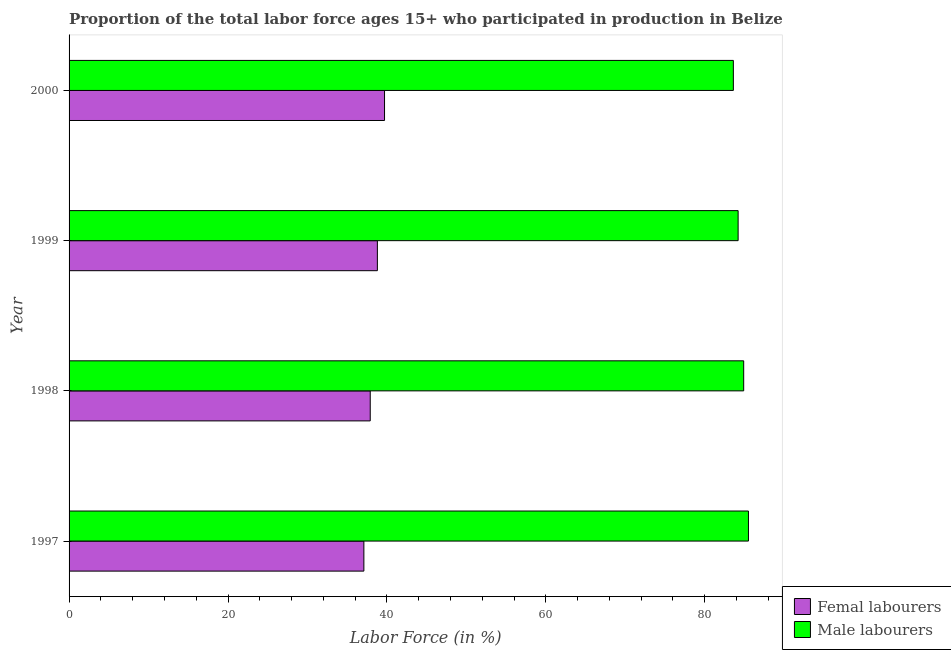How many different coloured bars are there?
Your answer should be very brief. 2. Are the number of bars per tick equal to the number of legend labels?
Your answer should be compact. Yes. Are the number of bars on each tick of the Y-axis equal?
Make the answer very short. Yes. How many bars are there on the 3rd tick from the top?
Ensure brevity in your answer.  2. What is the label of the 3rd group of bars from the top?
Provide a short and direct response. 1998. In how many cases, is the number of bars for a given year not equal to the number of legend labels?
Offer a terse response. 0. What is the percentage of male labour force in 2000?
Your answer should be compact. 83.6. Across all years, what is the maximum percentage of female labor force?
Your answer should be very brief. 39.7. Across all years, what is the minimum percentage of male labour force?
Offer a very short reply. 83.6. In which year was the percentage of male labour force maximum?
Offer a terse response. 1997. What is the total percentage of male labour force in the graph?
Ensure brevity in your answer.  338.2. What is the difference between the percentage of female labor force in 1997 and that in 1999?
Your response must be concise. -1.7. What is the difference between the percentage of male labour force in 1998 and the percentage of female labor force in 2000?
Make the answer very short. 45.2. What is the average percentage of female labor force per year?
Offer a very short reply. 38.38. In the year 1999, what is the difference between the percentage of female labor force and percentage of male labour force?
Provide a succinct answer. -45.4. What is the difference between the highest and the second highest percentage of male labour force?
Provide a succinct answer. 0.6. Is the sum of the percentage of male labour force in 1999 and 2000 greater than the maximum percentage of female labor force across all years?
Offer a very short reply. Yes. What does the 2nd bar from the top in 2000 represents?
Offer a very short reply. Femal labourers. What does the 1st bar from the bottom in 1998 represents?
Provide a short and direct response. Femal labourers. Are the values on the major ticks of X-axis written in scientific E-notation?
Provide a short and direct response. No. Does the graph contain any zero values?
Ensure brevity in your answer.  No. How many legend labels are there?
Your answer should be very brief. 2. How are the legend labels stacked?
Your answer should be very brief. Vertical. What is the title of the graph?
Give a very brief answer. Proportion of the total labor force ages 15+ who participated in production in Belize. Does "Transport services" appear as one of the legend labels in the graph?
Offer a very short reply. No. What is the Labor Force (in %) of Femal labourers in 1997?
Your answer should be compact. 37.1. What is the Labor Force (in %) of Male labourers in 1997?
Make the answer very short. 85.5. What is the Labor Force (in %) of Femal labourers in 1998?
Give a very brief answer. 37.9. What is the Labor Force (in %) in Male labourers in 1998?
Give a very brief answer. 84.9. What is the Labor Force (in %) in Femal labourers in 1999?
Give a very brief answer. 38.8. What is the Labor Force (in %) of Male labourers in 1999?
Provide a short and direct response. 84.2. What is the Labor Force (in %) of Femal labourers in 2000?
Keep it short and to the point. 39.7. What is the Labor Force (in %) in Male labourers in 2000?
Keep it short and to the point. 83.6. Across all years, what is the maximum Labor Force (in %) of Femal labourers?
Provide a succinct answer. 39.7. Across all years, what is the maximum Labor Force (in %) in Male labourers?
Ensure brevity in your answer.  85.5. Across all years, what is the minimum Labor Force (in %) of Femal labourers?
Offer a very short reply. 37.1. Across all years, what is the minimum Labor Force (in %) in Male labourers?
Make the answer very short. 83.6. What is the total Labor Force (in %) in Femal labourers in the graph?
Your response must be concise. 153.5. What is the total Labor Force (in %) in Male labourers in the graph?
Offer a terse response. 338.2. What is the difference between the Labor Force (in %) of Femal labourers in 1997 and that in 1998?
Keep it short and to the point. -0.8. What is the difference between the Labor Force (in %) of Male labourers in 1997 and that in 1999?
Your answer should be compact. 1.3. What is the difference between the Labor Force (in %) in Femal labourers in 1997 and that in 2000?
Ensure brevity in your answer.  -2.6. What is the difference between the Labor Force (in %) of Male labourers in 1997 and that in 2000?
Your response must be concise. 1.9. What is the difference between the Labor Force (in %) in Femal labourers in 1998 and that in 1999?
Provide a succinct answer. -0.9. What is the difference between the Labor Force (in %) of Male labourers in 1998 and that in 1999?
Offer a very short reply. 0.7. What is the difference between the Labor Force (in %) in Femal labourers in 1998 and that in 2000?
Your answer should be very brief. -1.8. What is the difference between the Labor Force (in %) in Femal labourers in 1999 and that in 2000?
Your answer should be very brief. -0.9. What is the difference between the Labor Force (in %) of Male labourers in 1999 and that in 2000?
Keep it short and to the point. 0.6. What is the difference between the Labor Force (in %) in Femal labourers in 1997 and the Labor Force (in %) in Male labourers in 1998?
Your response must be concise. -47.8. What is the difference between the Labor Force (in %) of Femal labourers in 1997 and the Labor Force (in %) of Male labourers in 1999?
Provide a succinct answer. -47.1. What is the difference between the Labor Force (in %) of Femal labourers in 1997 and the Labor Force (in %) of Male labourers in 2000?
Your answer should be compact. -46.5. What is the difference between the Labor Force (in %) of Femal labourers in 1998 and the Labor Force (in %) of Male labourers in 1999?
Your answer should be compact. -46.3. What is the difference between the Labor Force (in %) of Femal labourers in 1998 and the Labor Force (in %) of Male labourers in 2000?
Make the answer very short. -45.7. What is the difference between the Labor Force (in %) of Femal labourers in 1999 and the Labor Force (in %) of Male labourers in 2000?
Offer a terse response. -44.8. What is the average Labor Force (in %) of Femal labourers per year?
Your response must be concise. 38.38. What is the average Labor Force (in %) of Male labourers per year?
Your answer should be very brief. 84.55. In the year 1997, what is the difference between the Labor Force (in %) of Femal labourers and Labor Force (in %) of Male labourers?
Give a very brief answer. -48.4. In the year 1998, what is the difference between the Labor Force (in %) in Femal labourers and Labor Force (in %) in Male labourers?
Your response must be concise. -47. In the year 1999, what is the difference between the Labor Force (in %) in Femal labourers and Labor Force (in %) in Male labourers?
Provide a succinct answer. -45.4. In the year 2000, what is the difference between the Labor Force (in %) of Femal labourers and Labor Force (in %) of Male labourers?
Your answer should be very brief. -43.9. What is the ratio of the Labor Force (in %) of Femal labourers in 1997 to that in 1998?
Give a very brief answer. 0.98. What is the ratio of the Labor Force (in %) in Male labourers in 1997 to that in 1998?
Offer a very short reply. 1.01. What is the ratio of the Labor Force (in %) of Femal labourers in 1997 to that in 1999?
Offer a very short reply. 0.96. What is the ratio of the Labor Force (in %) of Male labourers in 1997 to that in 1999?
Ensure brevity in your answer.  1.02. What is the ratio of the Labor Force (in %) of Femal labourers in 1997 to that in 2000?
Ensure brevity in your answer.  0.93. What is the ratio of the Labor Force (in %) in Male labourers in 1997 to that in 2000?
Your response must be concise. 1.02. What is the ratio of the Labor Force (in %) of Femal labourers in 1998 to that in 1999?
Provide a short and direct response. 0.98. What is the ratio of the Labor Force (in %) of Male labourers in 1998 to that in 1999?
Your answer should be compact. 1.01. What is the ratio of the Labor Force (in %) of Femal labourers in 1998 to that in 2000?
Make the answer very short. 0.95. What is the ratio of the Labor Force (in %) in Male labourers in 1998 to that in 2000?
Your response must be concise. 1.02. What is the ratio of the Labor Force (in %) in Femal labourers in 1999 to that in 2000?
Your answer should be compact. 0.98. What is the difference between the highest and the second highest Labor Force (in %) of Femal labourers?
Offer a terse response. 0.9. What is the difference between the highest and the second highest Labor Force (in %) of Male labourers?
Provide a short and direct response. 0.6. What is the difference between the highest and the lowest Labor Force (in %) in Male labourers?
Offer a very short reply. 1.9. 